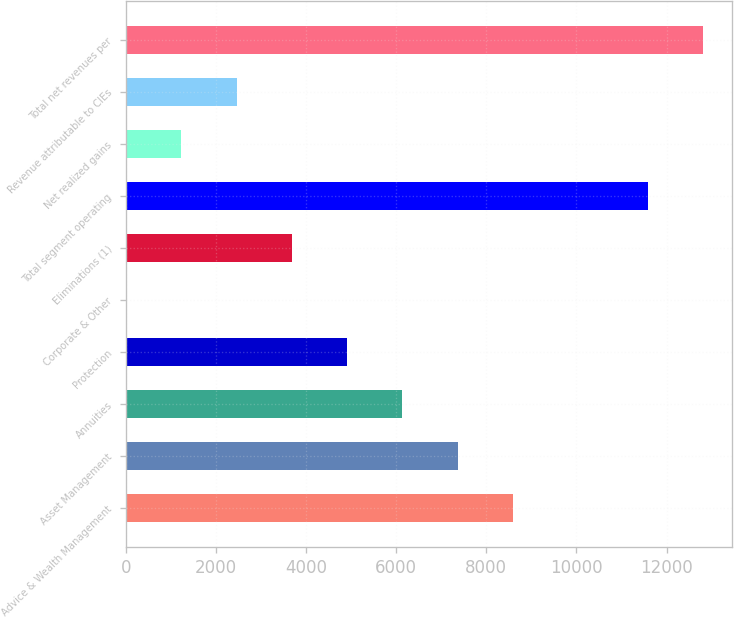<chart> <loc_0><loc_0><loc_500><loc_500><bar_chart><fcel>Advice & Wealth Management<fcel>Asset Management<fcel>Annuities<fcel>Protection<fcel>Corporate & Other<fcel>Eliminations (1)<fcel>Total segment operating<fcel>Net realized gains<fcel>Revenue attributable to CIEs<fcel>Total net revenues per<nl><fcel>8588.8<fcel>7362.4<fcel>6136<fcel>4909.6<fcel>4<fcel>3683.2<fcel>11591<fcel>1230.4<fcel>2456.8<fcel>12817.4<nl></chart> 